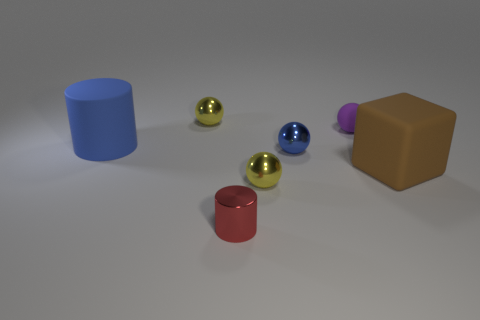Can you describe the color palette used in the image? The color palette of the image includes a variety of muted tones—a red cylinder, blue and purple blocks, along with reflective gold, silver, and blue spheres—set against a neutral grey background, creating a calm and balanced aesthetic. 